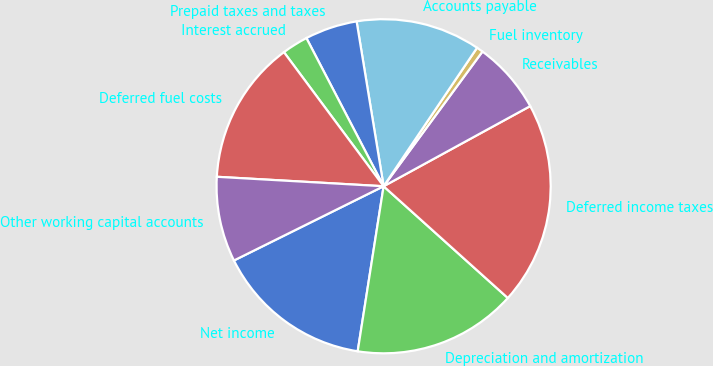Convert chart. <chart><loc_0><loc_0><loc_500><loc_500><pie_chart><fcel>Net income<fcel>Depreciation and amortization<fcel>Deferred income taxes<fcel>Receivables<fcel>Fuel inventory<fcel>Accounts payable<fcel>Prepaid taxes and taxes<fcel>Interest accrued<fcel>Deferred fuel costs<fcel>Other working capital accounts<nl><fcel>15.19%<fcel>15.82%<fcel>19.62%<fcel>6.96%<fcel>0.63%<fcel>12.03%<fcel>5.06%<fcel>2.53%<fcel>13.92%<fcel>8.23%<nl></chart> 